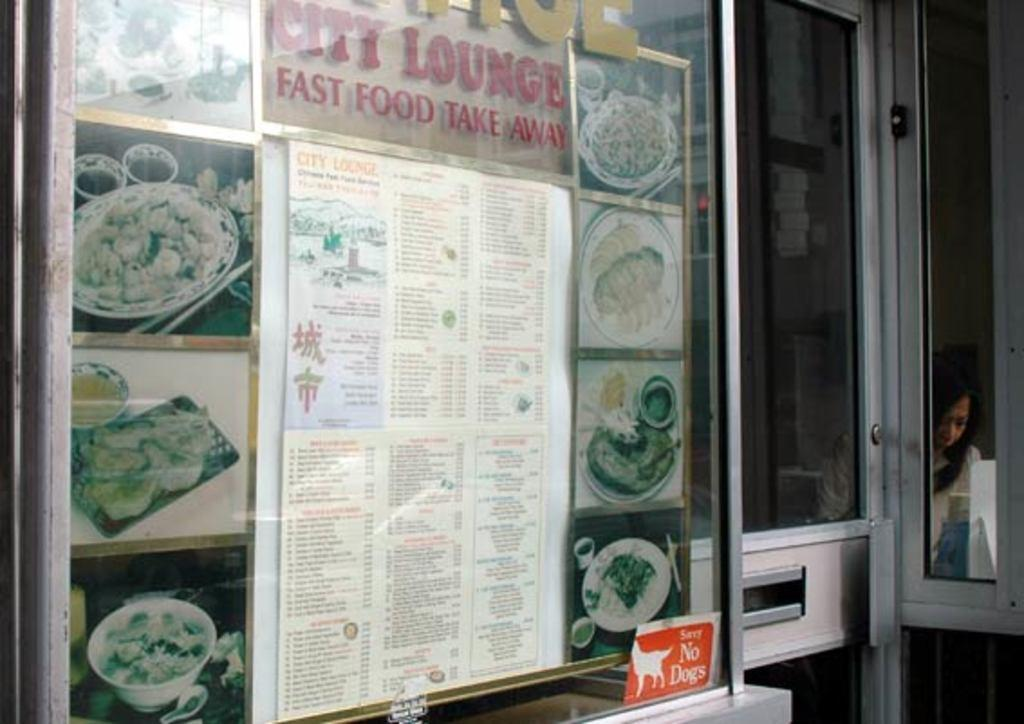<image>
Relay a brief, clear account of the picture shown. Outside a restaurant window wiht a sign that reads City Lounge Fast Food Take Away and a menu pasted on the window with food photos surrounding. 